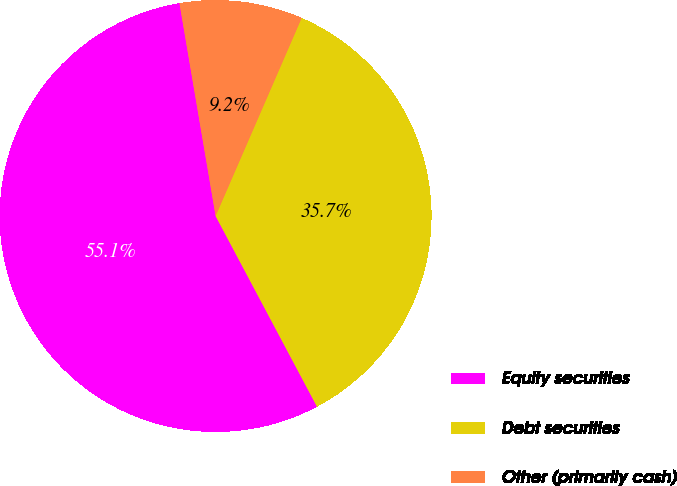Convert chart to OTSL. <chart><loc_0><loc_0><loc_500><loc_500><pie_chart><fcel>Equity securities<fcel>Debt securities<fcel>Other (primarily cash)<nl><fcel>55.1%<fcel>35.7%<fcel>9.2%<nl></chart> 